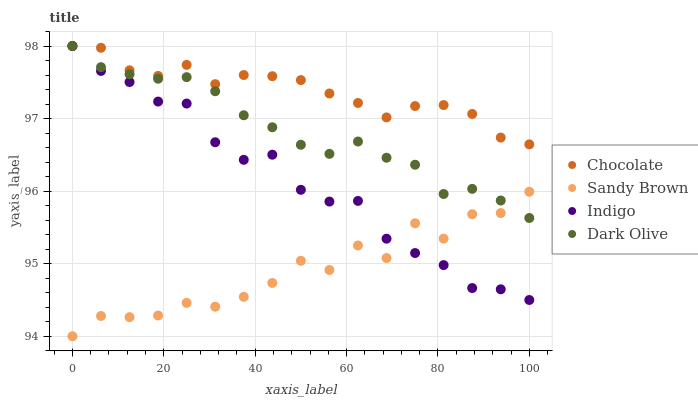Does Sandy Brown have the minimum area under the curve?
Answer yes or no. Yes. Does Chocolate have the maximum area under the curve?
Answer yes or no. Yes. Does Dark Olive have the minimum area under the curve?
Answer yes or no. No. Does Dark Olive have the maximum area under the curve?
Answer yes or no. No. Is Dark Olive the smoothest?
Answer yes or no. Yes. Is Sandy Brown the roughest?
Answer yes or no. Yes. Is Sandy Brown the smoothest?
Answer yes or no. No. Is Dark Olive the roughest?
Answer yes or no. No. Does Sandy Brown have the lowest value?
Answer yes or no. Yes. Does Dark Olive have the lowest value?
Answer yes or no. No. Does Chocolate have the highest value?
Answer yes or no. Yes. Does Sandy Brown have the highest value?
Answer yes or no. No. Is Sandy Brown less than Chocolate?
Answer yes or no. Yes. Is Chocolate greater than Sandy Brown?
Answer yes or no. Yes. Does Indigo intersect Dark Olive?
Answer yes or no. Yes. Is Indigo less than Dark Olive?
Answer yes or no. No. Is Indigo greater than Dark Olive?
Answer yes or no. No. Does Sandy Brown intersect Chocolate?
Answer yes or no. No. 